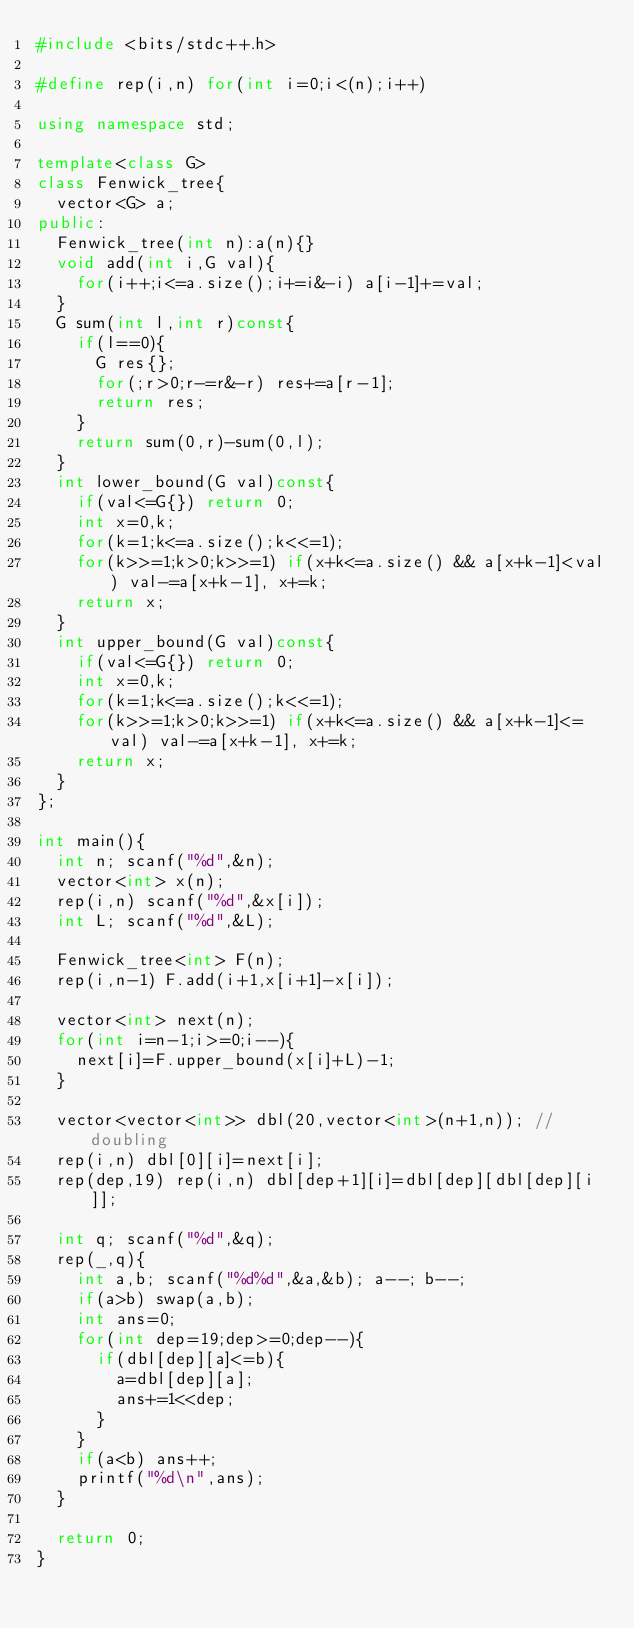<code> <loc_0><loc_0><loc_500><loc_500><_C++_>#include <bits/stdc++.h>

#define rep(i,n) for(int i=0;i<(n);i++)

using namespace std;

template<class G>
class Fenwick_tree{
	vector<G> a;
public:
	Fenwick_tree(int n):a(n){}
	void add(int i,G val){
		for(i++;i<=a.size();i+=i&-i) a[i-1]+=val;
	}
	G sum(int l,int r)const{
		if(l==0){
			G res{};
			for(;r>0;r-=r&-r) res+=a[r-1];
			return res;
		}
		return sum(0,r)-sum(0,l);
	}
	int lower_bound(G val)const{
		if(val<=G{}) return 0;
		int x=0,k;
		for(k=1;k<=a.size();k<<=1);
		for(k>>=1;k>0;k>>=1) if(x+k<=a.size() && a[x+k-1]<val) val-=a[x+k-1], x+=k;
		return x;
	}
	int upper_bound(G val)const{
		if(val<=G{}) return 0;
		int x=0,k;
		for(k=1;k<=a.size();k<<=1);
		for(k>>=1;k>0;k>>=1) if(x+k<=a.size() && a[x+k-1]<=val) val-=a[x+k-1], x+=k;
		return x;
	}
};

int main(){
	int n; scanf("%d",&n);
	vector<int> x(n);
	rep(i,n) scanf("%d",&x[i]);
	int L; scanf("%d",&L);

	Fenwick_tree<int> F(n);
	rep(i,n-1) F.add(i+1,x[i+1]-x[i]);

	vector<int> next(n);
	for(int i=n-1;i>=0;i--){
		next[i]=F.upper_bound(x[i]+L)-1;
	}

	vector<vector<int>> dbl(20,vector<int>(n+1,n)); // doubling
	rep(i,n) dbl[0][i]=next[i];
	rep(dep,19) rep(i,n) dbl[dep+1][i]=dbl[dep][dbl[dep][i]];

	int q; scanf("%d",&q);
	rep(_,q){
		int a,b; scanf("%d%d",&a,&b); a--; b--;
		if(a>b) swap(a,b);
		int ans=0;
		for(int dep=19;dep>=0;dep--){
			if(dbl[dep][a]<=b){
				a=dbl[dep][a];
				ans+=1<<dep;
			}
		}
		if(a<b) ans++;
		printf("%d\n",ans);
	}

	return 0;
}
</code> 